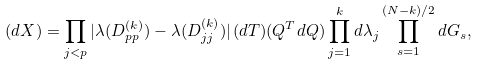<formula> <loc_0><loc_0><loc_500><loc_500>( d X ) = \prod _ { j < p } | \lambda ( D ^ { ( k ) } _ { p p } ) - \lambda ( D ^ { ( k ) } _ { j j } ) | \, ( d T ) ( Q ^ { T } d Q ) \prod _ { j = 1 } ^ { k } d \lambda _ { j } \prod _ { s = 1 } ^ { ( N - k ) / 2 } d G _ { s } ,</formula> 